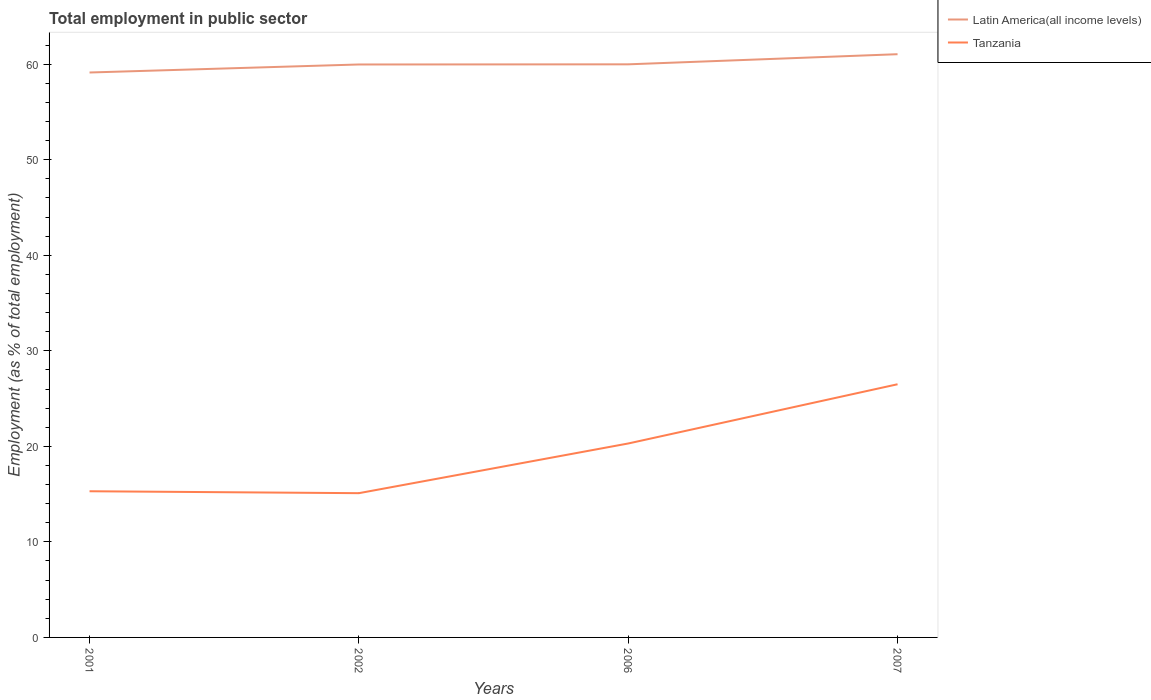How many different coloured lines are there?
Your response must be concise. 2. Does the line corresponding to Latin America(all income levels) intersect with the line corresponding to Tanzania?
Give a very brief answer. No. Is the number of lines equal to the number of legend labels?
Provide a succinct answer. Yes. Across all years, what is the maximum employment in public sector in Tanzania?
Offer a terse response. 15.1. In which year was the employment in public sector in Latin America(all income levels) maximum?
Provide a short and direct response. 2001. What is the total employment in public sector in Tanzania in the graph?
Your answer should be very brief. -11.2. What is the difference between the highest and the second highest employment in public sector in Tanzania?
Provide a succinct answer. 11.4. What is the difference between the highest and the lowest employment in public sector in Latin America(all income levels)?
Provide a succinct answer. 1. Is the employment in public sector in Latin America(all income levels) strictly greater than the employment in public sector in Tanzania over the years?
Make the answer very short. No. How many lines are there?
Offer a very short reply. 2. How many years are there in the graph?
Provide a short and direct response. 4. What is the difference between two consecutive major ticks on the Y-axis?
Offer a very short reply. 10. Does the graph contain any zero values?
Provide a succinct answer. No. Does the graph contain grids?
Give a very brief answer. No. What is the title of the graph?
Your answer should be compact. Total employment in public sector. Does "Fiji" appear as one of the legend labels in the graph?
Your answer should be compact. No. What is the label or title of the X-axis?
Keep it short and to the point. Years. What is the label or title of the Y-axis?
Provide a succinct answer. Employment (as % of total employment). What is the Employment (as % of total employment) of Latin America(all income levels) in 2001?
Keep it short and to the point. 59.13. What is the Employment (as % of total employment) of Tanzania in 2001?
Keep it short and to the point. 15.3. What is the Employment (as % of total employment) in Latin America(all income levels) in 2002?
Keep it short and to the point. 59.97. What is the Employment (as % of total employment) of Tanzania in 2002?
Provide a succinct answer. 15.1. What is the Employment (as % of total employment) in Latin America(all income levels) in 2006?
Keep it short and to the point. 59.99. What is the Employment (as % of total employment) in Tanzania in 2006?
Give a very brief answer. 20.3. What is the Employment (as % of total employment) in Latin America(all income levels) in 2007?
Make the answer very short. 61.05. Across all years, what is the maximum Employment (as % of total employment) of Latin America(all income levels)?
Offer a terse response. 61.05. Across all years, what is the minimum Employment (as % of total employment) in Latin America(all income levels)?
Provide a short and direct response. 59.13. Across all years, what is the minimum Employment (as % of total employment) in Tanzania?
Your answer should be very brief. 15.1. What is the total Employment (as % of total employment) in Latin America(all income levels) in the graph?
Your answer should be compact. 240.14. What is the total Employment (as % of total employment) of Tanzania in the graph?
Provide a short and direct response. 77.2. What is the difference between the Employment (as % of total employment) of Latin America(all income levels) in 2001 and that in 2002?
Keep it short and to the point. -0.84. What is the difference between the Employment (as % of total employment) of Latin America(all income levels) in 2001 and that in 2006?
Offer a very short reply. -0.86. What is the difference between the Employment (as % of total employment) of Tanzania in 2001 and that in 2006?
Keep it short and to the point. -5. What is the difference between the Employment (as % of total employment) in Latin America(all income levels) in 2001 and that in 2007?
Keep it short and to the point. -1.92. What is the difference between the Employment (as % of total employment) in Tanzania in 2001 and that in 2007?
Your answer should be very brief. -11.2. What is the difference between the Employment (as % of total employment) in Latin America(all income levels) in 2002 and that in 2006?
Offer a terse response. -0.02. What is the difference between the Employment (as % of total employment) in Tanzania in 2002 and that in 2006?
Your answer should be very brief. -5.2. What is the difference between the Employment (as % of total employment) of Latin America(all income levels) in 2002 and that in 2007?
Offer a terse response. -1.08. What is the difference between the Employment (as % of total employment) in Tanzania in 2002 and that in 2007?
Offer a terse response. -11.4. What is the difference between the Employment (as % of total employment) of Latin America(all income levels) in 2006 and that in 2007?
Provide a short and direct response. -1.06. What is the difference between the Employment (as % of total employment) in Latin America(all income levels) in 2001 and the Employment (as % of total employment) in Tanzania in 2002?
Provide a short and direct response. 44.03. What is the difference between the Employment (as % of total employment) of Latin America(all income levels) in 2001 and the Employment (as % of total employment) of Tanzania in 2006?
Your answer should be compact. 38.83. What is the difference between the Employment (as % of total employment) in Latin America(all income levels) in 2001 and the Employment (as % of total employment) in Tanzania in 2007?
Give a very brief answer. 32.63. What is the difference between the Employment (as % of total employment) in Latin America(all income levels) in 2002 and the Employment (as % of total employment) in Tanzania in 2006?
Your answer should be very brief. 39.67. What is the difference between the Employment (as % of total employment) in Latin America(all income levels) in 2002 and the Employment (as % of total employment) in Tanzania in 2007?
Your answer should be compact. 33.47. What is the difference between the Employment (as % of total employment) in Latin America(all income levels) in 2006 and the Employment (as % of total employment) in Tanzania in 2007?
Give a very brief answer. 33.49. What is the average Employment (as % of total employment) of Latin America(all income levels) per year?
Your answer should be very brief. 60.04. What is the average Employment (as % of total employment) of Tanzania per year?
Your answer should be very brief. 19.3. In the year 2001, what is the difference between the Employment (as % of total employment) in Latin America(all income levels) and Employment (as % of total employment) in Tanzania?
Give a very brief answer. 43.83. In the year 2002, what is the difference between the Employment (as % of total employment) in Latin America(all income levels) and Employment (as % of total employment) in Tanzania?
Make the answer very short. 44.87. In the year 2006, what is the difference between the Employment (as % of total employment) of Latin America(all income levels) and Employment (as % of total employment) of Tanzania?
Ensure brevity in your answer.  39.69. In the year 2007, what is the difference between the Employment (as % of total employment) of Latin America(all income levels) and Employment (as % of total employment) of Tanzania?
Keep it short and to the point. 34.55. What is the ratio of the Employment (as % of total employment) in Tanzania in 2001 to that in 2002?
Provide a succinct answer. 1.01. What is the ratio of the Employment (as % of total employment) in Latin America(all income levels) in 2001 to that in 2006?
Keep it short and to the point. 0.99. What is the ratio of the Employment (as % of total employment) in Tanzania in 2001 to that in 2006?
Provide a succinct answer. 0.75. What is the ratio of the Employment (as % of total employment) in Latin America(all income levels) in 2001 to that in 2007?
Make the answer very short. 0.97. What is the ratio of the Employment (as % of total employment) in Tanzania in 2001 to that in 2007?
Your response must be concise. 0.58. What is the ratio of the Employment (as % of total employment) of Tanzania in 2002 to that in 2006?
Offer a very short reply. 0.74. What is the ratio of the Employment (as % of total employment) in Latin America(all income levels) in 2002 to that in 2007?
Provide a succinct answer. 0.98. What is the ratio of the Employment (as % of total employment) of Tanzania in 2002 to that in 2007?
Make the answer very short. 0.57. What is the ratio of the Employment (as % of total employment) in Latin America(all income levels) in 2006 to that in 2007?
Ensure brevity in your answer.  0.98. What is the ratio of the Employment (as % of total employment) in Tanzania in 2006 to that in 2007?
Provide a short and direct response. 0.77. What is the difference between the highest and the second highest Employment (as % of total employment) in Latin America(all income levels)?
Offer a very short reply. 1.06. What is the difference between the highest and the lowest Employment (as % of total employment) in Latin America(all income levels)?
Your answer should be very brief. 1.92. What is the difference between the highest and the lowest Employment (as % of total employment) of Tanzania?
Give a very brief answer. 11.4. 